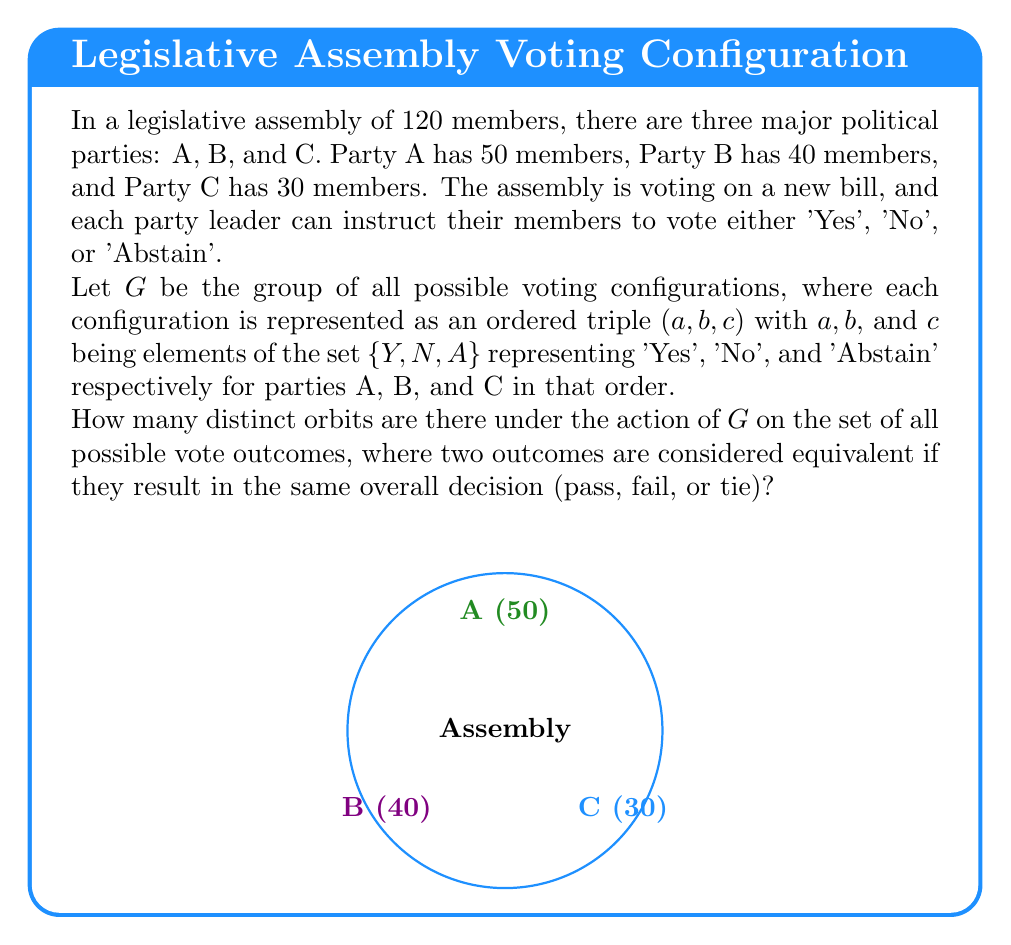Show me your answer to this math problem. Let's approach this step-by-step:

1) First, we need to understand what the group G looks like. It consists of all possible voting configurations:
   $G = \{(Y,Y,Y), (Y,Y,N), (Y,Y,A), (Y,N,Y), ..., (A,A,A)\}$
   There are $3^3 = 27$ elements in G.

2) Now, we need to consider how these configurations translate to outcomes. A bill passes if it gets more 'Yes' votes than 'No' votes, fails if it gets more 'No' votes than 'Yes' votes, and ties if 'Yes' and 'No' votes are equal.

3) Let's calculate the total votes for each configuration:
   - If Party A votes 'Yes': +50
   - If Party B votes 'Yes': +40
   - If Party C votes 'Yes': +30
   - If a party votes 'No', we subtract the same numbers
   - If a party abstains, it adds 0

4) Now, let's count the distinct orbits:

   Orbit 1 (Pass): Any configuration where 'Yes' votes > 'No' votes
   Examples: (Y,Y,Y), (Y,Y,A), (Y,Y,N), (Y,N,Y), (Y,A,Y), (N,Y,Y)

   Orbit 2 (Fail): Any configuration where 'No' votes > 'Yes' votes
   Examples: (N,N,N), (N,N,A), (N,N,Y), (N,Y,N), (N,A,N), (Y,N,N)

   Orbit 3 (Tie): Any configuration where 'Yes' votes = 'No' votes
   Examples: (Y,N,A), (N,Y,A), (A,Y,N), (A,N,Y)

5) These are all the possible distinct orbits under this action. Any voting configuration will result in one of these three outcomes.

Therefore, there are 3 distinct orbits under this group action.
Answer: 3 orbits 